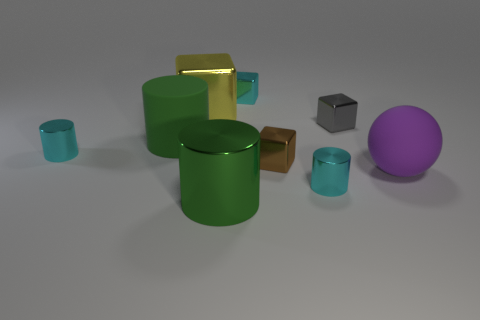Can you tell me the colors of the cylindrical objects and how many there are? There are three cylindrical objects in the image. Two are green and one is yellow. 